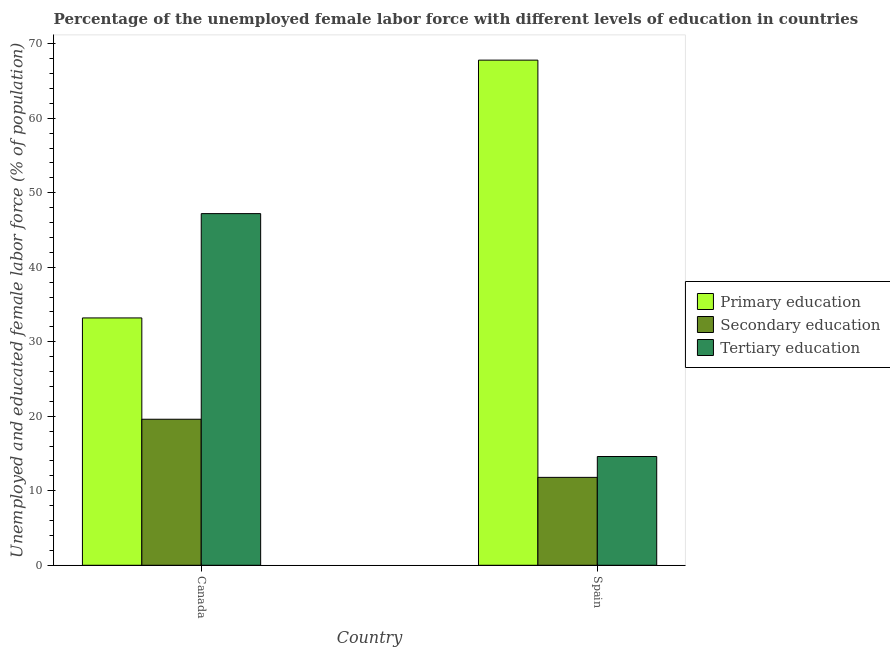How many bars are there on the 1st tick from the right?
Provide a succinct answer. 3. What is the percentage of female labor force who received tertiary education in Spain?
Offer a terse response. 14.6. Across all countries, what is the maximum percentage of female labor force who received tertiary education?
Keep it short and to the point. 47.2. Across all countries, what is the minimum percentage of female labor force who received primary education?
Your response must be concise. 33.2. In which country was the percentage of female labor force who received tertiary education maximum?
Your response must be concise. Canada. In which country was the percentage of female labor force who received secondary education minimum?
Offer a very short reply. Spain. What is the total percentage of female labor force who received tertiary education in the graph?
Provide a succinct answer. 61.8. What is the difference between the percentage of female labor force who received secondary education in Canada and that in Spain?
Keep it short and to the point. 7.8. What is the difference between the percentage of female labor force who received primary education in Canada and the percentage of female labor force who received tertiary education in Spain?
Give a very brief answer. 18.6. What is the average percentage of female labor force who received primary education per country?
Ensure brevity in your answer.  50.5. What is the difference between the percentage of female labor force who received secondary education and percentage of female labor force who received tertiary education in Canada?
Keep it short and to the point. -27.6. What is the ratio of the percentage of female labor force who received tertiary education in Canada to that in Spain?
Your answer should be very brief. 3.23. In how many countries, is the percentage of female labor force who received primary education greater than the average percentage of female labor force who received primary education taken over all countries?
Provide a short and direct response. 1. What does the 2nd bar from the left in Spain represents?
Provide a succinct answer. Secondary education. What does the 1st bar from the right in Spain represents?
Your response must be concise. Tertiary education. Is it the case that in every country, the sum of the percentage of female labor force who received primary education and percentage of female labor force who received secondary education is greater than the percentage of female labor force who received tertiary education?
Ensure brevity in your answer.  Yes. Are all the bars in the graph horizontal?
Provide a short and direct response. No. How many countries are there in the graph?
Your response must be concise. 2. What is the difference between two consecutive major ticks on the Y-axis?
Offer a terse response. 10. Are the values on the major ticks of Y-axis written in scientific E-notation?
Offer a terse response. No. Where does the legend appear in the graph?
Provide a short and direct response. Center right. How many legend labels are there?
Your answer should be compact. 3. How are the legend labels stacked?
Your answer should be compact. Vertical. What is the title of the graph?
Your answer should be very brief. Percentage of the unemployed female labor force with different levels of education in countries. Does "Female employers" appear as one of the legend labels in the graph?
Your answer should be compact. No. What is the label or title of the Y-axis?
Make the answer very short. Unemployed and educated female labor force (% of population). What is the Unemployed and educated female labor force (% of population) of Primary education in Canada?
Offer a terse response. 33.2. What is the Unemployed and educated female labor force (% of population) in Secondary education in Canada?
Make the answer very short. 19.6. What is the Unemployed and educated female labor force (% of population) in Tertiary education in Canada?
Keep it short and to the point. 47.2. What is the Unemployed and educated female labor force (% of population) of Primary education in Spain?
Provide a short and direct response. 67.8. What is the Unemployed and educated female labor force (% of population) in Secondary education in Spain?
Provide a succinct answer. 11.8. What is the Unemployed and educated female labor force (% of population) in Tertiary education in Spain?
Make the answer very short. 14.6. Across all countries, what is the maximum Unemployed and educated female labor force (% of population) in Primary education?
Give a very brief answer. 67.8. Across all countries, what is the maximum Unemployed and educated female labor force (% of population) in Secondary education?
Your answer should be compact. 19.6. Across all countries, what is the maximum Unemployed and educated female labor force (% of population) in Tertiary education?
Your answer should be compact. 47.2. Across all countries, what is the minimum Unemployed and educated female labor force (% of population) in Primary education?
Ensure brevity in your answer.  33.2. Across all countries, what is the minimum Unemployed and educated female labor force (% of population) of Secondary education?
Offer a very short reply. 11.8. Across all countries, what is the minimum Unemployed and educated female labor force (% of population) of Tertiary education?
Offer a very short reply. 14.6. What is the total Unemployed and educated female labor force (% of population) in Primary education in the graph?
Offer a very short reply. 101. What is the total Unemployed and educated female labor force (% of population) of Secondary education in the graph?
Ensure brevity in your answer.  31.4. What is the total Unemployed and educated female labor force (% of population) of Tertiary education in the graph?
Offer a terse response. 61.8. What is the difference between the Unemployed and educated female labor force (% of population) of Primary education in Canada and that in Spain?
Ensure brevity in your answer.  -34.6. What is the difference between the Unemployed and educated female labor force (% of population) in Tertiary education in Canada and that in Spain?
Keep it short and to the point. 32.6. What is the difference between the Unemployed and educated female labor force (% of population) of Primary education in Canada and the Unemployed and educated female labor force (% of population) of Secondary education in Spain?
Provide a succinct answer. 21.4. What is the difference between the Unemployed and educated female labor force (% of population) in Primary education in Canada and the Unemployed and educated female labor force (% of population) in Tertiary education in Spain?
Your answer should be compact. 18.6. What is the difference between the Unemployed and educated female labor force (% of population) of Secondary education in Canada and the Unemployed and educated female labor force (% of population) of Tertiary education in Spain?
Your response must be concise. 5. What is the average Unemployed and educated female labor force (% of population) in Primary education per country?
Provide a short and direct response. 50.5. What is the average Unemployed and educated female labor force (% of population) of Secondary education per country?
Your response must be concise. 15.7. What is the average Unemployed and educated female labor force (% of population) of Tertiary education per country?
Provide a short and direct response. 30.9. What is the difference between the Unemployed and educated female labor force (% of population) of Primary education and Unemployed and educated female labor force (% of population) of Secondary education in Canada?
Offer a terse response. 13.6. What is the difference between the Unemployed and educated female labor force (% of population) in Secondary education and Unemployed and educated female labor force (% of population) in Tertiary education in Canada?
Give a very brief answer. -27.6. What is the difference between the Unemployed and educated female labor force (% of population) of Primary education and Unemployed and educated female labor force (% of population) of Secondary education in Spain?
Make the answer very short. 56. What is the difference between the Unemployed and educated female labor force (% of population) of Primary education and Unemployed and educated female labor force (% of population) of Tertiary education in Spain?
Your answer should be very brief. 53.2. What is the difference between the Unemployed and educated female labor force (% of population) of Secondary education and Unemployed and educated female labor force (% of population) of Tertiary education in Spain?
Provide a succinct answer. -2.8. What is the ratio of the Unemployed and educated female labor force (% of population) of Primary education in Canada to that in Spain?
Your answer should be compact. 0.49. What is the ratio of the Unemployed and educated female labor force (% of population) of Secondary education in Canada to that in Spain?
Your answer should be compact. 1.66. What is the ratio of the Unemployed and educated female labor force (% of population) of Tertiary education in Canada to that in Spain?
Keep it short and to the point. 3.23. What is the difference between the highest and the second highest Unemployed and educated female labor force (% of population) of Primary education?
Ensure brevity in your answer.  34.6. What is the difference between the highest and the second highest Unemployed and educated female labor force (% of population) of Tertiary education?
Your answer should be very brief. 32.6. What is the difference between the highest and the lowest Unemployed and educated female labor force (% of population) in Primary education?
Your response must be concise. 34.6. What is the difference between the highest and the lowest Unemployed and educated female labor force (% of population) of Secondary education?
Offer a terse response. 7.8. What is the difference between the highest and the lowest Unemployed and educated female labor force (% of population) in Tertiary education?
Provide a short and direct response. 32.6. 